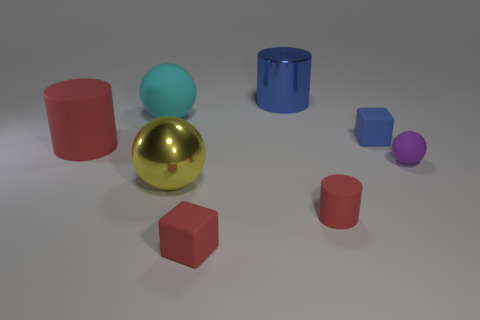The other rubber cylinder that is the same color as the big rubber cylinder is what size?
Provide a short and direct response. Small. What is the size of the blue thing to the right of the big blue metal thing?
Offer a very short reply. Small. Are there fewer big matte cylinders than tiny yellow matte blocks?
Give a very brief answer. No. Is the material of the big cylinder that is in front of the cyan sphere the same as the tiny red thing that is right of the red cube?
Your response must be concise. Yes. There is a rubber object behind the small thing that is behind the matte cylinder on the left side of the metal cylinder; what shape is it?
Offer a terse response. Sphere. How many large red cylinders have the same material as the large blue cylinder?
Give a very brief answer. 0. How many large blue cylinders are left of the rubber thing behind the blue rubber cube?
Your answer should be compact. 0. There is a matte cylinder in front of the large red thing; is its color the same as the block on the left side of the blue rubber thing?
Provide a succinct answer. Yes. There is a matte object that is both in front of the large matte sphere and on the left side of the red matte block; what shape is it?
Make the answer very short. Cylinder. Are there any cyan rubber things that have the same shape as the blue shiny thing?
Your response must be concise. No. 